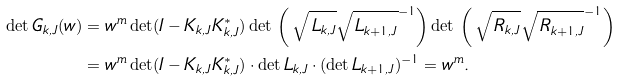<formula> <loc_0><loc_0><loc_500><loc_500>\det G _ { k , J } ( w ) & = w ^ { m } \det ( I - K _ { k , J } K _ { k , J } ^ { * } ) \det \, \left ( \, \sqrt { \, L _ { k , J } } \sqrt { \, L _ { k + 1 , J } } ^ { - 1 } \right ) \det \, \left ( \, \sqrt { \, R _ { k , J } } \sqrt { \, R _ { k + 1 , J } } ^ { - 1 } \right ) \\ & = w ^ { m } \det ( I - K _ { k , J } K _ { k , J } ^ { * } ) \cdot \det L _ { k , J } \cdot ( \det L _ { k + 1 , J } ) ^ { - 1 } = w ^ { m } .</formula> 